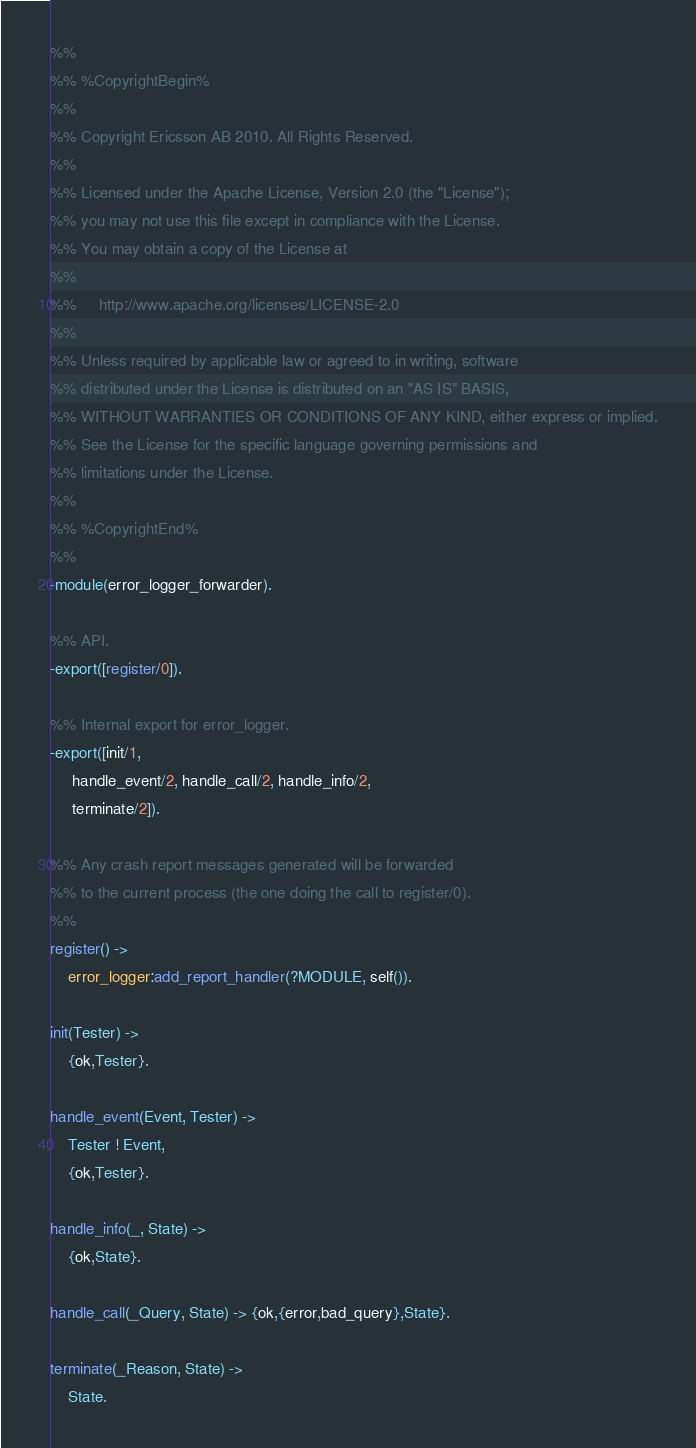<code> <loc_0><loc_0><loc_500><loc_500><_Erlang_>%%
%% %CopyrightBegin%
%% 
%% Copyright Ericsson AB 2010. All Rights Reserved.
%% 
%% Licensed under the Apache License, Version 2.0 (the "License");
%% you may not use this file except in compliance with the License.
%% You may obtain a copy of the License at
%%
%%     http://www.apache.org/licenses/LICENSE-2.0
%%
%% Unless required by applicable law or agreed to in writing, software
%% distributed under the License is distributed on an "AS IS" BASIS,
%% WITHOUT WARRANTIES OR CONDITIONS OF ANY KIND, either express or implied.
%% See the License for the specific language governing permissions and
%% limitations under the License.
%% 
%% %CopyrightEnd%
%%
-module(error_logger_forwarder).

%% API.
-export([register/0]).

%% Internal export for error_logger.
-export([init/1,
	 handle_event/2, handle_call/2, handle_info/2,
	 terminate/2]).

%% Any crash report messages generated will be forwarded
%% to the current process (the one doing the call to register/0).
%%
register() ->
    error_logger:add_report_handler(?MODULE, self()).

init(Tester) ->
    {ok,Tester}.
    
handle_event(Event, Tester) ->
    Tester ! Event,
    {ok,Tester}.

handle_info(_, State) ->
    {ok,State}.

handle_call(_Query, State) -> {ok,{error,bad_query},State}.

terminate(_Reason, State) ->
    State.
</code> 